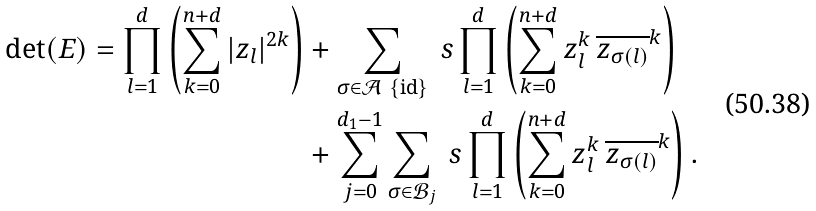<formula> <loc_0><loc_0><loc_500><loc_500>\det ( E ) = \prod _ { l = 1 } ^ { d } \left ( \sum _ { k = 0 } ^ { n + d } | z _ { l } | ^ { 2 k } \right ) & + \sum _ { \sigma \in \mathcal { A } \ \{ \text {id} \} } \ s \prod _ { l = 1 } ^ { d } \left ( \sum _ { k = 0 } ^ { n + d } z _ { l } ^ { k } \, \overline { z _ { \sigma ( l ) } } ^ { k } \right ) \\ & + \sum _ { j = 0 } ^ { d _ { 1 } - 1 } \sum _ { \sigma \in \mathcal { B } _ { j } } \ s \prod _ { l = 1 } ^ { d } \left ( \sum _ { k = 0 } ^ { n + d } z _ { l } ^ { k } \, \overline { z _ { \sigma ( l ) } } ^ { k } \right ) .</formula> 